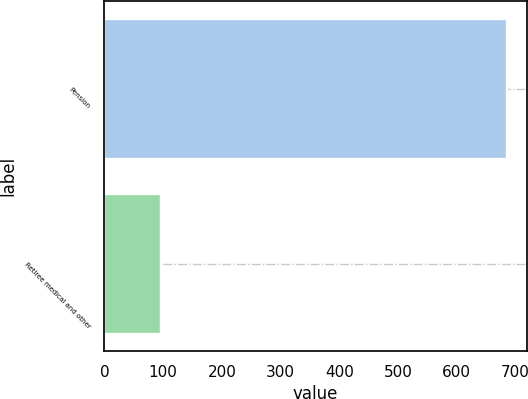Convert chart. <chart><loc_0><loc_0><loc_500><loc_500><bar_chart><fcel>Pension<fcel>Retiree medical and other<nl><fcel>685<fcel>97<nl></chart> 